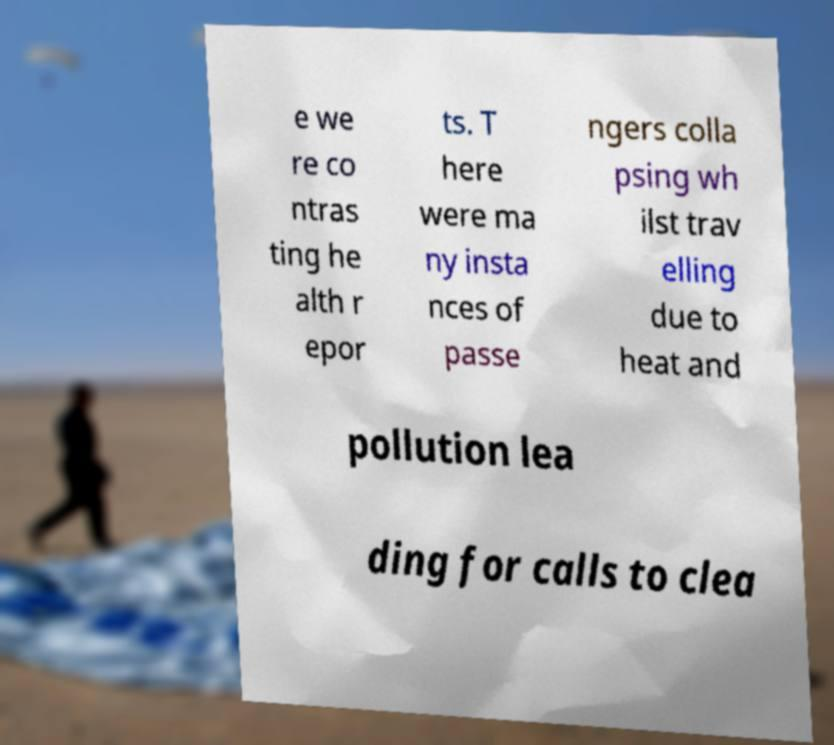For documentation purposes, I need the text within this image transcribed. Could you provide that? e we re co ntras ting he alth r epor ts. T here were ma ny insta nces of passe ngers colla psing wh ilst trav elling due to heat and pollution lea ding for calls to clea 